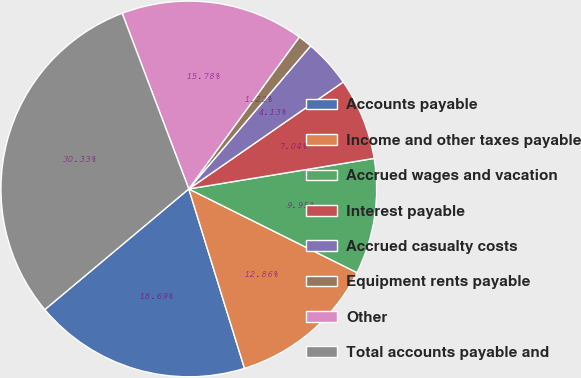<chart> <loc_0><loc_0><loc_500><loc_500><pie_chart><fcel>Accounts payable<fcel>Income and other taxes payable<fcel>Accrued wages and vacation<fcel>Interest payable<fcel>Accrued casualty costs<fcel>Equipment rents payable<fcel>Other<fcel>Total accounts payable and<nl><fcel>18.69%<fcel>12.86%<fcel>9.95%<fcel>7.04%<fcel>4.13%<fcel>1.22%<fcel>15.78%<fcel>30.33%<nl></chart> 